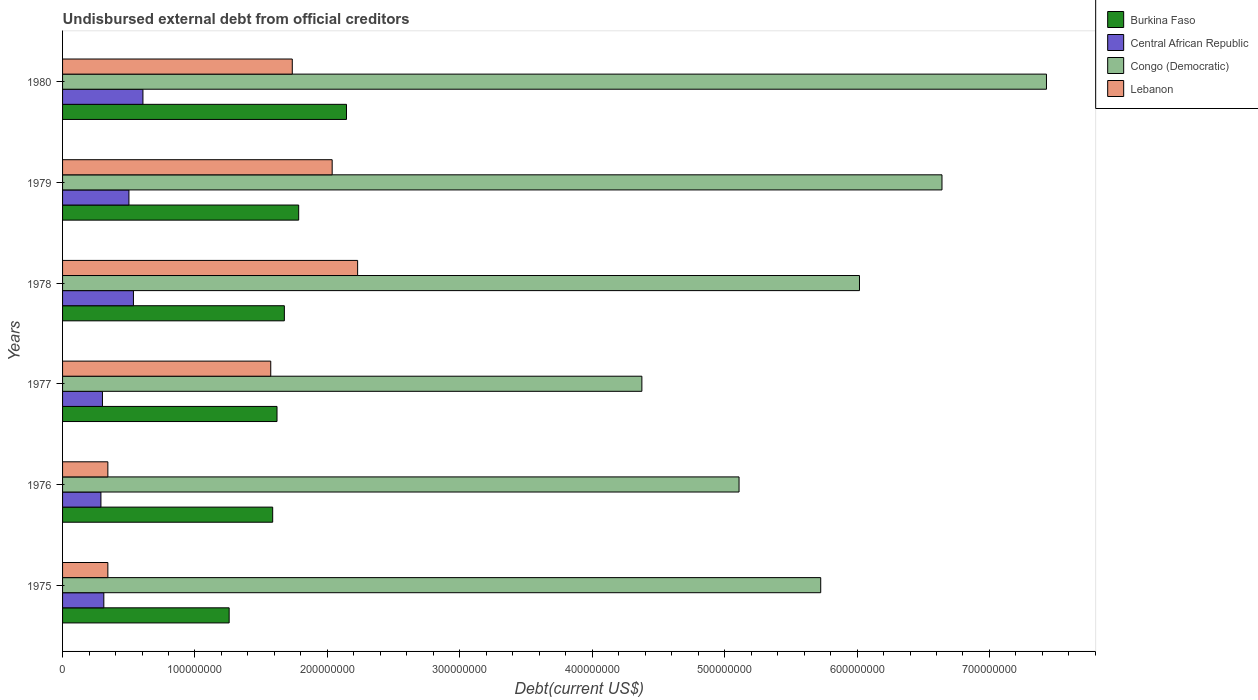How many groups of bars are there?
Ensure brevity in your answer.  6. Are the number of bars per tick equal to the number of legend labels?
Your answer should be very brief. Yes. What is the label of the 4th group of bars from the top?
Give a very brief answer. 1977. In how many cases, is the number of bars for a given year not equal to the number of legend labels?
Your answer should be compact. 0. What is the total debt in Congo (Democratic) in 1978?
Offer a very short reply. 6.02e+08. Across all years, what is the maximum total debt in Lebanon?
Your response must be concise. 2.23e+08. Across all years, what is the minimum total debt in Congo (Democratic)?
Your answer should be compact. 4.37e+08. What is the total total debt in Lebanon in the graph?
Give a very brief answer. 8.26e+08. What is the difference between the total debt in Congo (Democratic) in 1975 and that in 1978?
Offer a very short reply. -2.93e+07. What is the difference between the total debt in Central African Republic in 1979 and the total debt in Congo (Democratic) in 1976?
Provide a succinct answer. -4.61e+08. What is the average total debt in Congo (Democratic) per year?
Offer a very short reply. 5.88e+08. In the year 1976, what is the difference between the total debt in Lebanon and total debt in Congo (Democratic)?
Provide a succinct answer. -4.77e+08. In how many years, is the total debt in Central African Republic greater than 420000000 US$?
Offer a very short reply. 0. What is the ratio of the total debt in Burkina Faso in 1976 to that in 1978?
Offer a terse response. 0.95. What is the difference between the highest and the second highest total debt in Congo (Democratic)?
Ensure brevity in your answer.  7.89e+07. What is the difference between the highest and the lowest total debt in Congo (Democratic)?
Make the answer very short. 3.06e+08. In how many years, is the total debt in Central African Republic greater than the average total debt in Central African Republic taken over all years?
Provide a short and direct response. 3. What does the 1st bar from the top in 1976 represents?
Make the answer very short. Lebanon. What does the 2nd bar from the bottom in 1979 represents?
Ensure brevity in your answer.  Central African Republic. Are all the bars in the graph horizontal?
Give a very brief answer. Yes. Does the graph contain any zero values?
Give a very brief answer. No. How many legend labels are there?
Give a very brief answer. 4. How are the legend labels stacked?
Your answer should be very brief. Vertical. What is the title of the graph?
Your answer should be very brief. Undisbursed external debt from official creditors. Does "Haiti" appear as one of the legend labels in the graph?
Your answer should be compact. No. What is the label or title of the X-axis?
Ensure brevity in your answer.  Debt(current US$). What is the label or title of the Y-axis?
Keep it short and to the point. Years. What is the Debt(current US$) of Burkina Faso in 1975?
Give a very brief answer. 1.26e+08. What is the Debt(current US$) in Central African Republic in 1975?
Your answer should be compact. 3.12e+07. What is the Debt(current US$) in Congo (Democratic) in 1975?
Give a very brief answer. 5.73e+08. What is the Debt(current US$) in Lebanon in 1975?
Keep it short and to the point. 3.42e+07. What is the Debt(current US$) in Burkina Faso in 1976?
Your response must be concise. 1.59e+08. What is the Debt(current US$) of Central African Republic in 1976?
Offer a terse response. 2.90e+07. What is the Debt(current US$) of Congo (Democratic) in 1976?
Keep it short and to the point. 5.11e+08. What is the Debt(current US$) in Lebanon in 1976?
Provide a succinct answer. 3.42e+07. What is the Debt(current US$) of Burkina Faso in 1977?
Offer a very short reply. 1.62e+08. What is the Debt(current US$) in Central African Republic in 1977?
Provide a succinct answer. 3.01e+07. What is the Debt(current US$) of Congo (Democratic) in 1977?
Ensure brevity in your answer.  4.37e+08. What is the Debt(current US$) of Lebanon in 1977?
Provide a succinct answer. 1.57e+08. What is the Debt(current US$) in Burkina Faso in 1978?
Keep it short and to the point. 1.68e+08. What is the Debt(current US$) in Central African Republic in 1978?
Provide a succinct answer. 5.35e+07. What is the Debt(current US$) in Congo (Democratic) in 1978?
Provide a succinct answer. 6.02e+08. What is the Debt(current US$) of Lebanon in 1978?
Ensure brevity in your answer.  2.23e+08. What is the Debt(current US$) of Burkina Faso in 1979?
Provide a succinct answer. 1.78e+08. What is the Debt(current US$) of Central African Republic in 1979?
Offer a terse response. 5.01e+07. What is the Debt(current US$) in Congo (Democratic) in 1979?
Keep it short and to the point. 6.64e+08. What is the Debt(current US$) in Lebanon in 1979?
Ensure brevity in your answer.  2.04e+08. What is the Debt(current US$) in Burkina Faso in 1980?
Your answer should be compact. 2.14e+08. What is the Debt(current US$) of Central African Republic in 1980?
Provide a short and direct response. 6.07e+07. What is the Debt(current US$) in Congo (Democratic) in 1980?
Your response must be concise. 7.43e+08. What is the Debt(current US$) of Lebanon in 1980?
Ensure brevity in your answer.  1.73e+08. Across all years, what is the maximum Debt(current US$) in Burkina Faso?
Offer a very short reply. 2.14e+08. Across all years, what is the maximum Debt(current US$) of Central African Republic?
Ensure brevity in your answer.  6.07e+07. Across all years, what is the maximum Debt(current US$) of Congo (Democratic)?
Keep it short and to the point. 7.43e+08. Across all years, what is the maximum Debt(current US$) in Lebanon?
Keep it short and to the point. 2.23e+08. Across all years, what is the minimum Debt(current US$) of Burkina Faso?
Offer a terse response. 1.26e+08. Across all years, what is the minimum Debt(current US$) in Central African Republic?
Keep it short and to the point. 2.90e+07. Across all years, what is the minimum Debt(current US$) in Congo (Democratic)?
Provide a succinct answer. 4.37e+08. Across all years, what is the minimum Debt(current US$) of Lebanon?
Keep it short and to the point. 3.42e+07. What is the total Debt(current US$) in Burkina Faso in the graph?
Ensure brevity in your answer.  1.01e+09. What is the total Debt(current US$) of Central African Republic in the graph?
Your response must be concise. 2.55e+08. What is the total Debt(current US$) in Congo (Democratic) in the graph?
Offer a terse response. 3.53e+09. What is the total Debt(current US$) in Lebanon in the graph?
Provide a succinct answer. 8.26e+08. What is the difference between the Debt(current US$) in Burkina Faso in 1975 and that in 1976?
Your answer should be compact. -3.29e+07. What is the difference between the Debt(current US$) of Central African Republic in 1975 and that in 1976?
Provide a succinct answer. 2.20e+06. What is the difference between the Debt(current US$) of Congo (Democratic) in 1975 and that in 1976?
Give a very brief answer. 6.17e+07. What is the difference between the Debt(current US$) in Burkina Faso in 1975 and that in 1977?
Provide a succinct answer. -3.61e+07. What is the difference between the Debt(current US$) in Central African Republic in 1975 and that in 1977?
Offer a very short reply. 1.04e+06. What is the difference between the Debt(current US$) of Congo (Democratic) in 1975 and that in 1977?
Provide a short and direct response. 1.35e+08. What is the difference between the Debt(current US$) of Lebanon in 1975 and that in 1977?
Your answer should be very brief. -1.23e+08. What is the difference between the Debt(current US$) of Burkina Faso in 1975 and that in 1978?
Offer a terse response. -4.17e+07. What is the difference between the Debt(current US$) of Central African Republic in 1975 and that in 1978?
Keep it short and to the point. -2.24e+07. What is the difference between the Debt(current US$) in Congo (Democratic) in 1975 and that in 1978?
Your answer should be compact. -2.93e+07. What is the difference between the Debt(current US$) in Lebanon in 1975 and that in 1978?
Provide a short and direct response. -1.89e+08. What is the difference between the Debt(current US$) in Burkina Faso in 1975 and that in 1979?
Ensure brevity in your answer.  -5.25e+07. What is the difference between the Debt(current US$) in Central African Republic in 1975 and that in 1979?
Offer a very short reply. -1.90e+07. What is the difference between the Debt(current US$) of Congo (Democratic) in 1975 and that in 1979?
Keep it short and to the point. -9.16e+07. What is the difference between the Debt(current US$) in Lebanon in 1975 and that in 1979?
Keep it short and to the point. -1.69e+08. What is the difference between the Debt(current US$) of Burkina Faso in 1975 and that in 1980?
Ensure brevity in your answer.  -8.86e+07. What is the difference between the Debt(current US$) of Central African Republic in 1975 and that in 1980?
Your response must be concise. -2.95e+07. What is the difference between the Debt(current US$) of Congo (Democratic) in 1975 and that in 1980?
Keep it short and to the point. -1.70e+08. What is the difference between the Debt(current US$) in Lebanon in 1975 and that in 1980?
Provide a short and direct response. -1.39e+08. What is the difference between the Debt(current US$) of Burkina Faso in 1976 and that in 1977?
Provide a short and direct response. -3.26e+06. What is the difference between the Debt(current US$) of Central African Republic in 1976 and that in 1977?
Your response must be concise. -1.16e+06. What is the difference between the Debt(current US$) of Congo (Democratic) in 1976 and that in 1977?
Provide a short and direct response. 7.34e+07. What is the difference between the Debt(current US$) of Lebanon in 1976 and that in 1977?
Make the answer very short. -1.23e+08. What is the difference between the Debt(current US$) of Burkina Faso in 1976 and that in 1978?
Offer a very short reply. -8.82e+06. What is the difference between the Debt(current US$) of Central African Republic in 1976 and that in 1978?
Your answer should be compact. -2.46e+07. What is the difference between the Debt(current US$) of Congo (Democratic) in 1976 and that in 1978?
Make the answer very short. -9.09e+07. What is the difference between the Debt(current US$) in Lebanon in 1976 and that in 1978?
Ensure brevity in your answer.  -1.89e+08. What is the difference between the Debt(current US$) of Burkina Faso in 1976 and that in 1979?
Keep it short and to the point. -1.96e+07. What is the difference between the Debt(current US$) of Central African Republic in 1976 and that in 1979?
Your response must be concise. -2.12e+07. What is the difference between the Debt(current US$) in Congo (Democratic) in 1976 and that in 1979?
Offer a very short reply. -1.53e+08. What is the difference between the Debt(current US$) in Lebanon in 1976 and that in 1979?
Keep it short and to the point. -1.69e+08. What is the difference between the Debt(current US$) in Burkina Faso in 1976 and that in 1980?
Offer a very short reply. -5.57e+07. What is the difference between the Debt(current US$) of Central African Republic in 1976 and that in 1980?
Keep it short and to the point. -3.17e+07. What is the difference between the Debt(current US$) in Congo (Democratic) in 1976 and that in 1980?
Your answer should be very brief. -2.32e+08. What is the difference between the Debt(current US$) in Lebanon in 1976 and that in 1980?
Keep it short and to the point. -1.39e+08. What is the difference between the Debt(current US$) in Burkina Faso in 1977 and that in 1978?
Keep it short and to the point. -5.55e+06. What is the difference between the Debt(current US$) of Central African Republic in 1977 and that in 1978?
Give a very brief answer. -2.34e+07. What is the difference between the Debt(current US$) of Congo (Democratic) in 1977 and that in 1978?
Make the answer very short. -1.64e+08. What is the difference between the Debt(current US$) of Lebanon in 1977 and that in 1978?
Keep it short and to the point. -6.56e+07. What is the difference between the Debt(current US$) of Burkina Faso in 1977 and that in 1979?
Offer a terse response. -1.64e+07. What is the difference between the Debt(current US$) in Central African Republic in 1977 and that in 1979?
Your response must be concise. -2.00e+07. What is the difference between the Debt(current US$) of Congo (Democratic) in 1977 and that in 1979?
Your response must be concise. -2.27e+08. What is the difference between the Debt(current US$) in Lebanon in 1977 and that in 1979?
Offer a very short reply. -4.64e+07. What is the difference between the Debt(current US$) of Burkina Faso in 1977 and that in 1980?
Keep it short and to the point. -5.25e+07. What is the difference between the Debt(current US$) of Central African Republic in 1977 and that in 1980?
Give a very brief answer. -3.06e+07. What is the difference between the Debt(current US$) of Congo (Democratic) in 1977 and that in 1980?
Keep it short and to the point. -3.06e+08. What is the difference between the Debt(current US$) of Lebanon in 1977 and that in 1980?
Ensure brevity in your answer.  -1.63e+07. What is the difference between the Debt(current US$) in Burkina Faso in 1978 and that in 1979?
Ensure brevity in your answer.  -1.08e+07. What is the difference between the Debt(current US$) of Central African Republic in 1978 and that in 1979?
Provide a short and direct response. 3.40e+06. What is the difference between the Debt(current US$) of Congo (Democratic) in 1978 and that in 1979?
Offer a very short reply. -6.23e+07. What is the difference between the Debt(current US$) in Lebanon in 1978 and that in 1979?
Give a very brief answer. 1.92e+07. What is the difference between the Debt(current US$) of Burkina Faso in 1978 and that in 1980?
Offer a terse response. -4.69e+07. What is the difference between the Debt(current US$) of Central African Republic in 1978 and that in 1980?
Your response must be concise. -7.17e+06. What is the difference between the Debt(current US$) of Congo (Democratic) in 1978 and that in 1980?
Ensure brevity in your answer.  -1.41e+08. What is the difference between the Debt(current US$) of Lebanon in 1978 and that in 1980?
Offer a terse response. 4.94e+07. What is the difference between the Debt(current US$) in Burkina Faso in 1979 and that in 1980?
Offer a very short reply. -3.61e+07. What is the difference between the Debt(current US$) in Central African Republic in 1979 and that in 1980?
Keep it short and to the point. -1.06e+07. What is the difference between the Debt(current US$) in Congo (Democratic) in 1979 and that in 1980?
Provide a short and direct response. -7.89e+07. What is the difference between the Debt(current US$) of Lebanon in 1979 and that in 1980?
Make the answer very short. 3.01e+07. What is the difference between the Debt(current US$) of Burkina Faso in 1975 and the Debt(current US$) of Central African Republic in 1976?
Your response must be concise. 9.68e+07. What is the difference between the Debt(current US$) in Burkina Faso in 1975 and the Debt(current US$) in Congo (Democratic) in 1976?
Your answer should be very brief. -3.85e+08. What is the difference between the Debt(current US$) in Burkina Faso in 1975 and the Debt(current US$) in Lebanon in 1976?
Make the answer very short. 9.16e+07. What is the difference between the Debt(current US$) in Central African Republic in 1975 and the Debt(current US$) in Congo (Democratic) in 1976?
Provide a short and direct response. -4.80e+08. What is the difference between the Debt(current US$) of Central African Republic in 1975 and the Debt(current US$) of Lebanon in 1976?
Your answer should be compact. -3.05e+06. What is the difference between the Debt(current US$) of Congo (Democratic) in 1975 and the Debt(current US$) of Lebanon in 1976?
Give a very brief answer. 5.38e+08. What is the difference between the Debt(current US$) of Burkina Faso in 1975 and the Debt(current US$) of Central African Republic in 1977?
Provide a succinct answer. 9.57e+07. What is the difference between the Debt(current US$) in Burkina Faso in 1975 and the Debt(current US$) in Congo (Democratic) in 1977?
Offer a terse response. -3.12e+08. What is the difference between the Debt(current US$) of Burkina Faso in 1975 and the Debt(current US$) of Lebanon in 1977?
Offer a very short reply. -3.14e+07. What is the difference between the Debt(current US$) in Central African Republic in 1975 and the Debt(current US$) in Congo (Democratic) in 1977?
Provide a succinct answer. -4.06e+08. What is the difference between the Debt(current US$) of Central African Republic in 1975 and the Debt(current US$) of Lebanon in 1977?
Your answer should be very brief. -1.26e+08. What is the difference between the Debt(current US$) of Congo (Democratic) in 1975 and the Debt(current US$) of Lebanon in 1977?
Provide a succinct answer. 4.15e+08. What is the difference between the Debt(current US$) of Burkina Faso in 1975 and the Debt(current US$) of Central African Republic in 1978?
Give a very brief answer. 7.23e+07. What is the difference between the Debt(current US$) of Burkina Faso in 1975 and the Debt(current US$) of Congo (Democratic) in 1978?
Make the answer very short. -4.76e+08. What is the difference between the Debt(current US$) of Burkina Faso in 1975 and the Debt(current US$) of Lebanon in 1978?
Offer a very short reply. -9.70e+07. What is the difference between the Debt(current US$) of Central African Republic in 1975 and the Debt(current US$) of Congo (Democratic) in 1978?
Provide a short and direct response. -5.71e+08. What is the difference between the Debt(current US$) of Central African Republic in 1975 and the Debt(current US$) of Lebanon in 1978?
Your answer should be compact. -1.92e+08. What is the difference between the Debt(current US$) of Congo (Democratic) in 1975 and the Debt(current US$) of Lebanon in 1978?
Your response must be concise. 3.50e+08. What is the difference between the Debt(current US$) in Burkina Faso in 1975 and the Debt(current US$) in Central African Republic in 1979?
Provide a succinct answer. 7.57e+07. What is the difference between the Debt(current US$) of Burkina Faso in 1975 and the Debt(current US$) of Congo (Democratic) in 1979?
Ensure brevity in your answer.  -5.38e+08. What is the difference between the Debt(current US$) of Burkina Faso in 1975 and the Debt(current US$) of Lebanon in 1979?
Keep it short and to the point. -7.78e+07. What is the difference between the Debt(current US$) in Central African Republic in 1975 and the Debt(current US$) in Congo (Democratic) in 1979?
Your answer should be very brief. -6.33e+08. What is the difference between the Debt(current US$) of Central African Republic in 1975 and the Debt(current US$) of Lebanon in 1979?
Ensure brevity in your answer.  -1.72e+08. What is the difference between the Debt(current US$) in Congo (Democratic) in 1975 and the Debt(current US$) in Lebanon in 1979?
Keep it short and to the point. 3.69e+08. What is the difference between the Debt(current US$) of Burkina Faso in 1975 and the Debt(current US$) of Central African Republic in 1980?
Provide a short and direct response. 6.51e+07. What is the difference between the Debt(current US$) in Burkina Faso in 1975 and the Debt(current US$) in Congo (Democratic) in 1980?
Offer a very short reply. -6.17e+08. What is the difference between the Debt(current US$) of Burkina Faso in 1975 and the Debt(current US$) of Lebanon in 1980?
Provide a short and direct response. -4.77e+07. What is the difference between the Debt(current US$) of Central African Republic in 1975 and the Debt(current US$) of Congo (Democratic) in 1980?
Your response must be concise. -7.12e+08. What is the difference between the Debt(current US$) in Central African Republic in 1975 and the Debt(current US$) in Lebanon in 1980?
Make the answer very short. -1.42e+08. What is the difference between the Debt(current US$) in Congo (Democratic) in 1975 and the Debt(current US$) in Lebanon in 1980?
Keep it short and to the point. 3.99e+08. What is the difference between the Debt(current US$) in Burkina Faso in 1976 and the Debt(current US$) in Central African Republic in 1977?
Provide a succinct answer. 1.29e+08. What is the difference between the Debt(current US$) in Burkina Faso in 1976 and the Debt(current US$) in Congo (Democratic) in 1977?
Offer a very short reply. -2.79e+08. What is the difference between the Debt(current US$) of Burkina Faso in 1976 and the Debt(current US$) of Lebanon in 1977?
Provide a short and direct response. 1.47e+06. What is the difference between the Debt(current US$) of Central African Republic in 1976 and the Debt(current US$) of Congo (Democratic) in 1977?
Keep it short and to the point. -4.09e+08. What is the difference between the Debt(current US$) in Central African Republic in 1976 and the Debt(current US$) in Lebanon in 1977?
Keep it short and to the point. -1.28e+08. What is the difference between the Debt(current US$) in Congo (Democratic) in 1976 and the Debt(current US$) in Lebanon in 1977?
Make the answer very short. 3.54e+08. What is the difference between the Debt(current US$) in Burkina Faso in 1976 and the Debt(current US$) in Central African Republic in 1978?
Offer a terse response. 1.05e+08. What is the difference between the Debt(current US$) of Burkina Faso in 1976 and the Debt(current US$) of Congo (Democratic) in 1978?
Ensure brevity in your answer.  -4.43e+08. What is the difference between the Debt(current US$) of Burkina Faso in 1976 and the Debt(current US$) of Lebanon in 1978?
Keep it short and to the point. -6.41e+07. What is the difference between the Debt(current US$) of Central African Republic in 1976 and the Debt(current US$) of Congo (Democratic) in 1978?
Offer a terse response. -5.73e+08. What is the difference between the Debt(current US$) in Central African Republic in 1976 and the Debt(current US$) in Lebanon in 1978?
Your answer should be compact. -1.94e+08. What is the difference between the Debt(current US$) in Congo (Democratic) in 1976 and the Debt(current US$) in Lebanon in 1978?
Offer a very short reply. 2.88e+08. What is the difference between the Debt(current US$) of Burkina Faso in 1976 and the Debt(current US$) of Central African Republic in 1979?
Keep it short and to the point. 1.09e+08. What is the difference between the Debt(current US$) of Burkina Faso in 1976 and the Debt(current US$) of Congo (Democratic) in 1979?
Offer a terse response. -5.05e+08. What is the difference between the Debt(current US$) in Burkina Faso in 1976 and the Debt(current US$) in Lebanon in 1979?
Make the answer very short. -4.49e+07. What is the difference between the Debt(current US$) of Central African Republic in 1976 and the Debt(current US$) of Congo (Democratic) in 1979?
Your response must be concise. -6.35e+08. What is the difference between the Debt(current US$) of Central African Republic in 1976 and the Debt(current US$) of Lebanon in 1979?
Offer a terse response. -1.75e+08. What is the difference between the Debt(current US$) in Congo (Democratic) in 1976 and the Debt(current US$) in Lebanon in 1979?
Your answer should be compact. 3.07e+08. What is the difference between the Debt(current US$) in Burkina Faso in 1976 and the Debt(current US$) in Central African Republic in 1980?
Offer a very short reply. 9.80e+07. What is the difference between the Debt(current US$) of Burkina Faso in 1976 and the Debt(current US$) of Congo (Democratic) in 1980?
Give a very brief answer. -5.84e+08. What is the difference between the Debt(current US$) of Burkina Faso in 1976 and the Debt(current US$) of Lebanon in 1980?
Ensure brevity in your answer.  -1.48e+07. What is the difference between the Debt(current US$) of Central African Republic in 1976 and the Debt(current US$) of Congo (Democratic) in 1980?
Keep it short and to the point. -7.14e+08. What is the difference between the Debt(current US$) in Central African Republic in 1976 and the Debt(current US$) in Lebanon in 1980?
Provide a succinct answer. -1.45e+08. What is the difference between the Debt(current US$) of Congo (Democratic) in 1976 and the Debt(current US$) of Lebanon in 1980?
Offer a terse response. 3.37e+08. What is the difference between the Debt(current US$) in Burkina Faso in 1977 and the Debt(current US$) in Central African Republic in 1978?
Ensure brevity in your answer.  1.08e+08. What is the difference between the Debt(current US$) in Burkina Faso in 1977 and the Debt(current US$) in Congo (Democratic) in 1978?
Provide a succinct answer. -4.40e+08. What is the difference between the Debt(current US$) of Burkina Faso in 1977 and the Debt(current US$) of Lebanon in 1978?
Offer a terse response. -6.09e+07. What is the difference between the Debt(current US$) of Central African Republic in 1977 and the Debt(current US$) of Congo (Democratic) in 1978?
Ensure brevity in your answer.  -5.72e+08. What is the difference between the Debt(current US$) in Central African Republic in 1977 and the Debt(current US$) in Lebanon in 1978?
Make the answer very short. -1.93e+08. What is the difference between the Debt(current US$) in Congo (Democratic) in 1977 and the Debt(current US$) in Lebanon in 1978?
Ensure brevity in your answer.  2.15e+08. What is the difference between the Debt(current US$) of Burkina Faso in 1977 and the Debt(current US$) of Central African Republic in 1979?
Keep it short and to the point. 1.12e+08. What is the difference between the Debt(current US$) of Burkina Faso in 1977 and the Debt(current US$) of Congo (Democratic) in 1979?
Give a very brief answer. -5.02e+08. What is the difference between the Debt(current US$) of Burkina Faso in 1977 and the Debt(current US$) of Lebanon in 1979?
Your response must be concise. -4.17e+07. What is the difference between the Debt(current US$) in Central African Republic in 1977 and the Debt(current US$) in Congo (Democratic) in 1979?
Provide a short and direct response. -6.34e+08. What is the difference between the Debt(current US$) in Central African Republic in 1977 and the Debt(current US$) in Lebanon in 1979?
Provide a short and direct response. -1.73e+08. What is the difference between the Debt(current US$) of Congo (Democratic) in 1977 and the Debt(current US$) of Lebanon in 1979?
Your response must be concise. 2.34e+08. What is the difference between the Debt(current US$) of Burkina Faso in 1977 and the Debt(current US$) of Central African Republic in 1980?
Give a very brief answer. 1.01e+08. What is the difference between the Debt(current US$) of Burkina Faso in 1977 and the Debt(current US$) of Congo (Democratic) in 1980?
Ensure brevity in your answer.  -5.81e+08. What is the difference between the Debt(current US$) in Burkina Faso in 1977 and the Debt(current US$) in Lebanon in 1980?
Your answer should be very brief. -1.15e+07. What is the difference between the Debt(current US$) in Central African Republic in 1977 and the Debt(current US$) in Congo (Democratic) in 1980?
Give a very brief answer. -7.13e+08. What is the difference between the Debt(current US$) in Central African Republic in 1977 and the Debt(current US$) in Lebanon in 1980?
Your answer should be very brief. -1.43e+08. What is the difference between the Debt(current US$) in Congo (Democratic) in 1977 and the Debt(current US$) in Lebanon in 1980?
Provide a succinct answer. 2.64e+08. What is the difference between the Debt(current US$) of Burkina Faso in 1978 and the Debt(current US$) of Central African Republic in 1979?
Make the answer very short. 1.17e+08. What is the difference between the Debt(current US$) in Burkina Faso in 1978 and the Debt(current US$) in Congo (Democratic) in 1979?
Keep it short and to the point. -4.97e+08. What is the difference between the Debt(current US$) of Burkina Faso in 1978 and the Debt(current US$) of Lebanon in 1979?
Offer a terse response. -3.61e+07. What is the difference between the Debt(current US$) of Central African Republic in 1978 and the Debt(current US$) of Congo (Democratic) in 1979?
Ensure brevity in your answer.  -6.11e+08. What is the difference between the Debt(current US$) of Central African Republic in 1978 and the Debt(current US$) of Lebanon in 1979?
Provide a succinct answer. -1.50e+08. What is the difference between the Debt(current US$) of Congo (Democratic) in 1978 and the Debt(current US$) of Lebanon in 1979?
Keep it short and to the point. 3.98e+08. What is the difference between the Debt(current US$) of Burkina Faso in 1978 and the Debt(current US$) of Central African Republic in 1980?
Offer a very short reply. 1.07e+08. What is the difference between the Debt(current US$) in Burkina Faso in 1978 and the Debt(current US$) in Congo (Democratic) in 1980?
Offer a terse response. -5.76e+08. What is the difference between the Debt(current US$) of Burkina Faso in 1978 and the Debt(current US$) of Lebanon in 1980?
Give a very brief answer. -5.97e+06. What is the difference between the Debt(current US$) of Central African Republic in 1978 and the Debt(current US$) of Congo (Democratic) in 1980?
Your answer should be very brief. -6.90e+08. What is the difference between the Debt(current US$) in Central African Republic in 1978 and the Debt(current US$) in Lebanon in 1980?
Offer a terse response. -1.20e+08. What is the difference between the Debt(current US$) in Congo (Democratic) in 1978 and the Debt(current US$) in Lebanon in 1980?
Provide a succinct answer. 4.28e+08. What is the difference between the Debt(current US$) of Burkina Faso in 1979 and the Debt(current US$) of Central African Republic in 1980?
Ensure brevity in your answer.  1.18e+08. What is the difference between the Debt(current US$) of Burkina Faso in 1979 and the Debt(current US$) of Congo (Democratic) in 1980?
Your answer should be very brief. -5.65e+08. What is the difference between the Debt(current US$) in Burkina Faso in 1979 and the Debt(current US$) in Lebanon in 1980?
Provide a succinct answer. 4.84e+06. What is the difference between the Debt(current US$) of Central African Republic in 1979 and the Debt(current US$) of Congo (Democratic) in 1980?
Make the answer very short. -6.93e+08. What is the difference between the Debt(current US$) in Central African Republic in 1979 and the Debt(current US$) in Lebanon in 1980?
Your answer should be very brief. -1.23e+08. What is the difference between the Debt(current US$) in Congo (Democratic) in 1979 and the Debt(current US$) in Lebanon in 1980?
Make the answer very short. 4.91e+08. What is the average Debt(current US$) in Burkina Faso per year?
Your response must be concise. 1.68e+08. What is the average Debt(current US$) in Central African Republic per year?
Make the answer very short. 4.24e+07. What is the average Debt(current US$) in Congo (Democratic) per year?
Offer a terse response. 5.88e+08. What is the average Debt(current US$) of Lebanon per year?
Provide a succinct answer. 1.38e+08. In the year 1975, what is the difference between the Debt(current US$) of Burkina Faso and Debt(current US$) of Central African Republic?
Your answer should be compact. 9.46e+07. In the year 1975, what is the difference between the Debt(current US$) of Burkina Faso and Debt(current US$) of Congo (Democratic)?
Keep it short and to the point. -4.47e+08. In the year 1975, what is the difference between the Debt(current US$) in Burkina Faso and Debt(current US$) in Lebanon?
Make the answer very short. 9.16e+07. In the year 1975, what is the difference between the Debt(current US$) in Central African Republic and Debt(current US$) in Congo (Democratic)?
Provide a short and direct response. -5.41e+08. In the year 1975, what is the difference between the Debt(current US$) in Central African Republic and Debt(current US$) in Lebanon?
Your answer should be compact. -3.05e+06. In the year 1975, what is the difference between the Debt(current US$) of Congo (Democratic) and Debt(current US$) of Lebanon?
Ensure brevity in your answer.  5.38e+08. In the year 1976, what is the difference between the Debt(current US$) of Burkina Faso and Debt(current US$) of Central African Republic?
Offer a terse response. 1.30e+08. In the year 1976, what is the difference between the Debt(current US$) in Burkina Faso and Debt(current US$) in Congo (Democratic)?
Keep it short and to the point. -3.52e+08. In the year 1976, what is the difference between the Debt(current US$) in Burkina Faso and Debt(current US$) in Lebanon?
Provide a succinct answer. 1.24e+08. In the year 1976, what is the difference between the Debt(current US$) of Central African Republic and Debt(current US$) of Congo (Democratic)?
Your answer should be compact. -4.82e+08. In the year 1976, what is the difference between the Debt(current US$) in Central African Republic and Debt(current US$) in Lebanon?
Keep it short and to the point. -5.24e+06. In the year 1976, what is the difference between the Debt(current US$) in Congo (Democratic) and Debt(current US$) in Lebanon?
Ensure brevity in your answer.  4.77e+08. In the year 1977, what is the difference between the Debt(current US$) in Burkina Faso and Debt(current US$) in Central African Republic?
Your answer should be compact. 1.32e+08. In the year 1977, what is the difference between the Debt(current US$) of Burkina Faso and Debt(current US$) of Congo (Democratic)?
Provide a short and direct response. -2.76e+08. In the year 1977, what is the difference between the Debt(current US$) of Burkina Faso and Debt(current US$) of Lebanon?
Offer a very short reply. 4.73e+06. In the year 1977, what is the difference between the Debt(current US$) in Central African Republic and Debt(current US$) in Congo (Democratic)?
Provide a short and direct response. -4.07e+08. In the year 1977, what is the difference between the Debt(current US$) of Central African Republic and Debt(current US$) of Lebanon?
Your response must be concise. -1.27e+08. In the year 1977, what is the difference between the Debt(current US$) of Congo (Democratic) and Debt(current US$) of Lebanon?
Provide a short and direct response. 2.80e+08. In the year 1978, what is the difference between the Debt(current US$) in Burkina Faso and Debt(current US$) in Central African Republic?
Your answer should be compact. 1.14e+08. In the year 1978, what is the difference between the Debt(current US$) in Burkina Faso and Debt(current US$) in Congo (Democratic)?
Make the answer very short. -4.34e+08. In the year 1978, what is the difference between the Debt(current US$) of Burkina Faso and Debt(current US$) of Lebanon?
Your answer should be very brief. -5.53e+07. In the year 1978, what is the difference between the Debt(current US$) in Central African Republic and Debt(current US$) in Congo (Democratic)?
Your response must be concise. -5.48e+08. In the year 1978, what is the difference between the Debt(current US$) of Central African Republic and Debt(current US$) of Lebanon?
Make the answer very short. -1.69e+08. In the year 1978, what is the difference between the Debt(current US$) in Congo (Democratic) and Debt(current US$) in Lebanon?
Keep it short and to the point. 3.79e+08. In the year 1979, what is the difference between the Debt(current US$) of Burkina Faso and Debt(current US$) of Central African Republic?
Your answer should be compact. 1.28e+08. In the year 1979, what is the difference between the Debt(current US$) of Burkina Faso and Debt(current US$) of Congo (Democratic)?
Your answer should be very brief. -4.86e+08. In the year 1979, what is the difference between the Debt(current US$) of Burkina Faso and Debt(current US$) of Lebanon?
Provide a short and direct response. -2.53e+07. In the year 1979, what is the difference between the Debt(current US$) in Central African Republic and Debt(current US$) in Congo (Democratic)?
Offer a terse response. -6.14e+08. In the year 1979, what is the difference between the Debt(current US$) of Central African Republic and Debt(current US$) of Lebanon?
Offer a very short reply. -1.53e+08. In the year 1979, what is the difference between the Debt(current US$) of Congo (Democratic) and Debt(current US$) of Lebanon?
Make the answer very short. 4.61e+08. In the year 1980, what is the difference between the Debt(current US$) in Burkina Faso and Debt(current US$) in Central African Republic?
Give a very brief answer. 1.54e+08. In the year 1980, what is the difference between the Debt(current US$) in Burkina Faso and Debt(current US$) in Congo (Democratic)?
Keep it short and to the point. -5.29e+08. In the year 1980, what is the difference between the Debt(current US$) of Burkina Faso and Debt(current US$) of Lebanon?
Make the answer very short. 4.09e+07. In the year 1980, what is the difference between the Debt(current US$) of Central African Republic and Debt(current US$) of Congo (Democratic)?
Offer a very short reply. -6.82e+08. In the year 1980, what is the difference between the Debt(current US$) in Central African Republic and Debt(current US$) in Lebanon?
Your response must be concise. -1.13e+08. In the year 1980, what is the difference between the Debt(current US$) in Congo (Democratic) and Debt(current US$) in Lebanon?
Keep it short and to the point. 5.70e+08. What is the ratio of the Debt(current US$) in Burkina Faso in 1975 to that in 1976?
Provide a short and direct response. 0.79. What is the ratio of the Debt(current US$) of Central African Republic in 1975 to that in 1976?
Your answer should be compact. 1.08. What is the ratio of the Debt(current US$) in Congo (Democratic) in 1975 to that in 1976?
Provide a short and direct response. 1.12. What is the ratio of the Debt(current US$) of Lebanon in 1975 to that in 1976?
Ensure brevity in your answer.  1. What is the ratio of the Debt(current US$) of Burkina Faso in 1975 to that in 1977?
Give a very brief answer. 0.78. What is the ratio of the Debt(current US$) in Central African Republic in 1975 to that in 1977?
Offer a very short reply. 1.03. What is the ratio of the Debt(current US$) in Congo (Democratic) in 1975 to that in 1977?
Provide a short and direct response. 1.31. What is the ratio of the Debt(current US$) in Lebanon in 1975 to that in 1977?
Your response must be concise. 0.22. What is the ratio of the Debt(current US$) in Burkina Faso in 1975 to that in 1978?
Give a very brief answer. 0.75. What is the ratio of the Debt(current US$) in Central African Republic in 1975 to that in 1978?
Your answer should be very brief. 0.58. What is the ratio of the Debt(current US$) in Congo (Democratic) in 1975 to that in 1978?
Offer a very short reply. 0.95. What is the ratio of the Debt(current US$) of Lebanon in 1975 to that in 1978?
Provide a succinct answer. 0.15. What is the ratio of the Debt(current US$) in Burkina Faso in 1975 to that in 1979?
Offer a very short reply. 0.71. What is the ratio of the Debt(current US$) in Central African Republic in 1975 to that in 1979?
Ensure brevity in your answer.  0.62. What is the ratio of the Debt(current US$) in Congo (Democratic) in 1975 to that in 1979?
Your answer should be very brief. 0.86. What is the ratio of the Debt(current US$) of Lebanon in 1975 to that in 1979?
Keep it short and to the point. 0.17. What is the ratio of the Debt(current US$) in Burkina Faso in 1975 to that in 1980?
Make the answer very short. 0.59. What is the ratio of the Debt(current US$) in Central African Republic in 1975 to that in 1980?
Give a very brief answer. 0.51. What is the ratio of the Debt(current US$) of Congo (Democratic) in 1975 to that in 1980?
Provide a succinct answer. 0.77. What is the ratio of the Debt(current US$) in Lebanon in 1975 to that in 1980?
Your answer should be compact. 0.2. What is the ratio of the Debt(current US$) of Burkina Faso in 1976 to that in 1977?
Keep it short and to the point. 0.98. What is the ratio of the Debt(current US$) in Central African Republic in 1976 to that in 1977?
Provide a short and direct response. 0.96. What is the ratio of the Debt(current US$) in Congo (Democratic) in 1976 to that in 1977?
Make the answer very short. 1.17. What is the ratio of the Debt(current US$) in Lebanon in 1976 to that in 1977?
Your answer should be very brief. 0.22. What is the ratio of the Debt(current US$) in Burkina Faso in 1976 to that in 1978?
Give a very brief answer. 0.95. What is the ratio of the Debt(current US$) in Central African Republic in 1976 to that in 1978?
Your response must be concise. 0.54. What is the ratio of the Debt(current US$) in Congo (Democratic) in 1976 to that in 1978?
Your response must be concise. 0.85. What is the ratio of the Debt(current US$) in Lebanon in 1976 to that in 1978?
Your response must be concise. 0.15. What is the ratio of the Debt(current US$) in Burkina Faso in 1976 to that in 1979?
Your answer should be very brief. 0.89. What is the ratio of the Debt(current US$) of Central African Republic in 1976 to that in 1979?
Keep it short and to the point. 0.58. What is the ratio of the Debt(current US$) of Congo (Democratic) in 1976 to that in 1979?
Offer a terse response. 0.77. What is the ratio of the Debt(current US$) in Lebanon in 1976 to that in 1979?
Keep it short and to the point. 0.17. What is the ratio of the Debt(current US$) in Burkina Faso in 1976 to that in 1980?
Provide a short and direct response. 0.74. What is the ratio of the Debt(current US$) in Central African Republic in 1976 to that in 1980?
Provide a succinct answer. 0.48. What is the ratio of the Debt(current US$) of Congo (Democratic) in 1976 to that in 1980?
Offer a terse response. 0.69. What is the ratio of the Debt(current US$) of Lebanon in 1976 to that in 1980?
Your answer should be very brief. 0.2. What is the ratio of the Debt(current US$) in Burkina Faso in 1977 to that in 1978?
Provide a succinct answer. 0.97. What is the ratio of the Debt(current US$) in Central African Republic in 1977 to that in 1978?
Keep it short and to the point. 0.56. What is the ratio of the Debt(current US$) of Congo (Democratic) in 1977 to that in 1978?
Keep it short and to the point. 0.73. What is the ratio of the Debt(current US$) of Lebanon in 1977 to that in 1978?
Provide a succinct answer. 0.71. What is the ratio of the Debt(current US$) of Burkina Faso in 1977 to that in 1979?
Your response must be concise. 0.91. What is the ratio of the Debt(current US$) in Central African Republic in 1977 to that in 1979?
Provide a short and direct response. 0.6. What is the ratio of the Debt(current US$) of Congo (Democratic) in 1977 to that in 1979?
Your answer should be compact. 0.66. What is the ratio of the Debt(current US$) in Lebanon in 1977 to that in 1979?
Offer a terse response. 0.77. What is the ratio of the Debt(current US$) of Burkina Faso in 1977 to that in 1980?
Offer a very short reply. 0.76. What is the ratio of the Debt(current US$) of Central African Republic in 1977 to that in 1980?
Your answer should be very brief. 0.5. What is the ratio of the Debt(current US$) in Congo (Democratic) in 1977 to that in 1980?
Keep it short and to the point. 0.59. What is the ratio of the Debt(current US$) in Lebanon in 1977 to that in 1980?
Your response must be concise. 0.91. What is the ratio of the Debt(current US$) of Burkina Faso in 1978 to that in 1979?
Offer a very short reply. 0.94. What is the ratio of the Debt(current US$) of Central African Republic in 1978 to that in 1979?
Keep it short and to the point. 1.07. What is the ratio of the Debt(current US$) of Congo (Democratic) in 1978 to that in 1979?
Keep it short and to the point. 0.91. What is the ratio of the Debt(current US$) of Lebanon in 1978 to that in 1979?
Provide a short and direct response. 1.09. What is the ratio of the Debt(current US$) in Burkina Faso in 1978 to that in 1980?
Ensure brevity in your answer.  0.78. What is the ratio of the Debt(current US$) in Central African Republic in 1978 to that in 1980?
Your answer should be compact. 0.88. What is the ratio of the Debt(current US$) in Congo (Democratic) in 1978 to that in 1980?
Keep it short and to the point. 0.81. What is the ratio of the Debt(current US$) in Lebanon in 1978 to that in 1980?
Offer a terse response. 1.28. What is the ratio of the Debt(current US$) in Burkina Faso in 1979 to that in 1980?
Offer a very short reply. 0.83. What is the ratio of the Debt(current US$) in Central African Republic in 1979 to that in 1980?
Your response must be concise. 0.83. What is the ratio of the Debt(current US$) in Congo (Democratic) in 1979 to that in 1980?
Give a very brief answer. 0.89. What is the ratio of the Debt(current US$) of Lebanon in 1979 to that in 1980?
Make the answer very short. 1.17. What is the difference between the highest and the second highest Debt(current US$) of Burkina Faso?
Your answer should be very brief. 3.61e+07. What is the difference between the highest and the second highest Debt(current US$) of Central African Republic?
Offer a very short reply. 7.17e+06. What is the difference between the highest and the second highest Debt(current US$) of Congo (Democratic)?
Provide a succinct answer. 7.89e+07. What is the difference between the highest and the second highest Debt(current US$) in Lebanon?
Your response must be concise. 1.92e+07. What is the difference between the highest and the lowest Debt(current US$) of Burkina Faso?
Make the answer very short. 8.86e+07. What is the difference between the highest and the lowest Debt(current US$) in Central African Republic?
Provide a short and direct response. 3.17e+07. What is the difference between the highest and the lowest Debt(current US$) of Congo (Democratic)?
Your answer should be compact. 3.06e+08. What is the difference between the highest and the lowest Debt(current US$) in Lebanon?
Make the answer very short. 1.89e+08. 